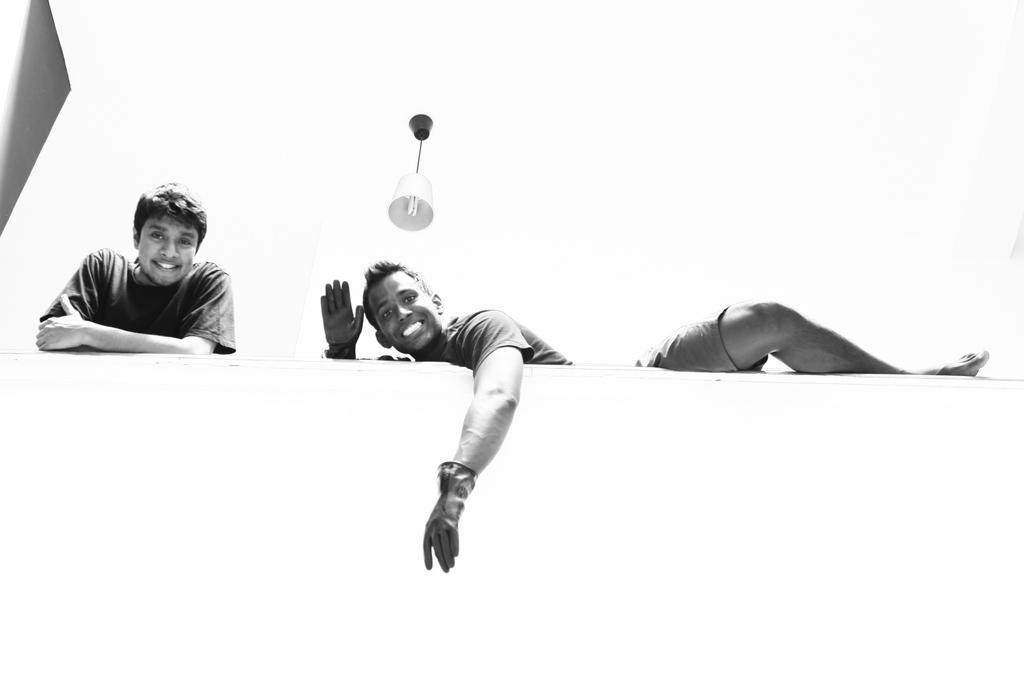Could you give a brief overview of what you see in this image? This is a black and white image, in this image there is a person standing near a wall and another person laying on the wall, at the top there is a light. 